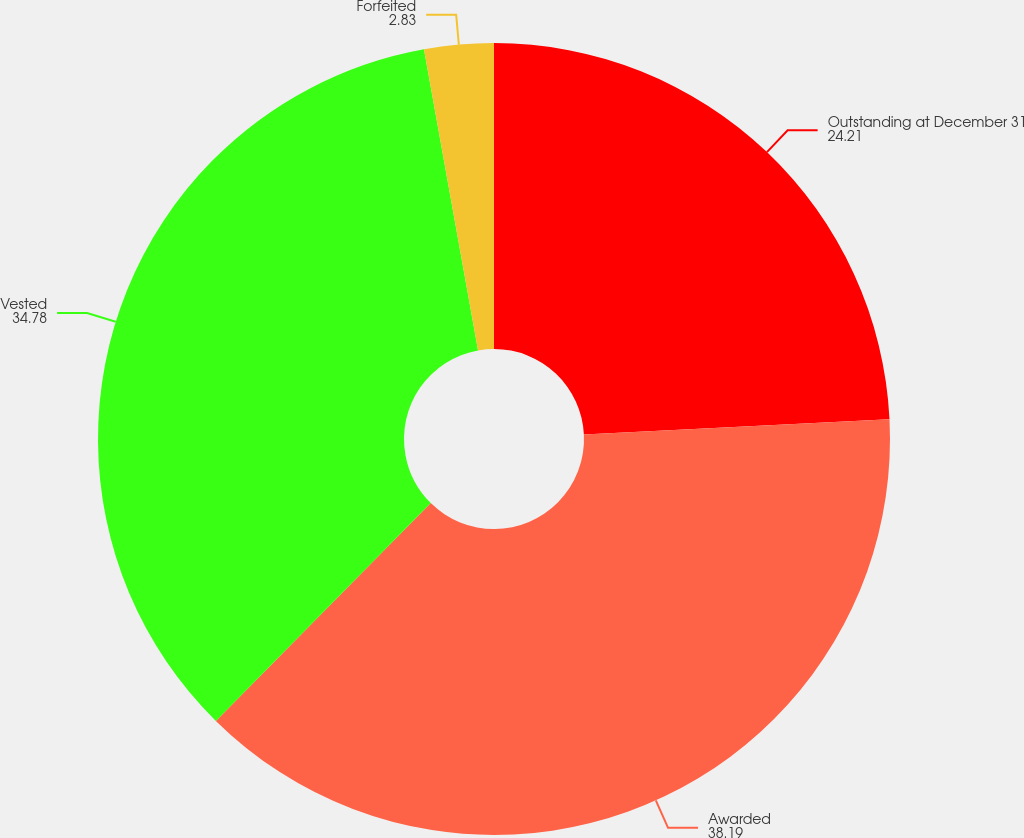Convert chart to OTSL. <chart><loc_0><loc_0><loc_500><loc_500><pie_chart><fcel>Outstanding at December 31<fcel>Awarded<fcel>Vested<fcel>Forfeited<nl><fcel>24.21%<fcel>38.19%<fcel>34.78%<fcel>2.83%<nl></chart> 